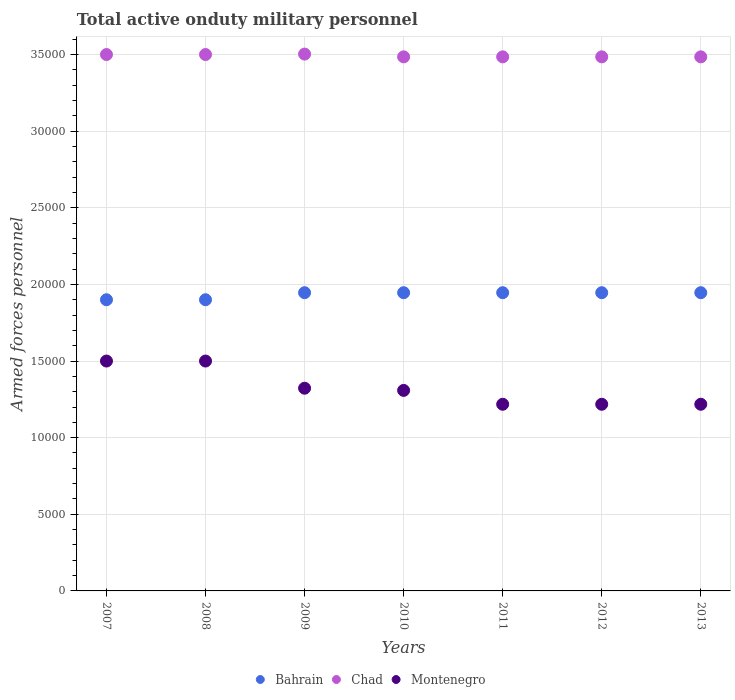Is the number of dotlines equal to the number of legend labels?
Your response must be concise. Yes. What is the number of armed forces personnel in Montenegro in 2011?
Make the answer very short. 1.22e+04. Across all years, what is the maximum number of armed forces personnel in Montenegro?
Provide a short and direct response. 1.50e+04. Across all years, what is the minimum number of armed forces personnel in Montenegro?
Your answer should be very brief. 1.22e+04. In which year was the number of armed forces personnel in Montenegro maximum?
Your answer should be compact. 2007. In which year was the number of armed forces personnel in Chad minimum?
Offer a very short reply. 2010. What is the total number of armed forces personnel in Bahrain in the graph?
Your answer should be very brief. 1.35e+05. What is the difference between the number of armed forces personnel in Montenegro in 2010 and that in 2013?
Your answer should be very brief. 904. What is the difference between the number of armed forces personnel in Montenegro in 2010 and the number of armed forces personnel in Chad in 2009?
Provide a short and direct response. -2.19e+04. What is the average number of armed forces personnel in Bahrain per year?
Provide a short and direct response. 1.93e+04. In the year 2007, what is the difference between the number of armed forces personnel in Montenegro and number of armed forces personnel in Chad?
Your answer should be compact. -2.00e+04. What is the ratio of the number of armed forces personnel in Chad in 2009 to that in 2013?
Your answer should be compact. 1.01. Is the difference between the number of armed forces personnel in Montenegro in 2010 and 2012 greater than the difference between the number of armed forces personnel in Chad in 2010 and 2012?
Offer a very short reply. Yes. What is the difference between the highest and the lowest number of armed forces personnel in Chad?
Offer a terse response. 180. Is the sum of the number of armed forces personnel in Montenegro in 2012 and 2013 greater than the maximum number of armed forces personnel in Bahrain across all years?
Your response must be concise. Yes. Is it the case that in every year, the sum of the number of armed forces personnel in Bahrain and number of armed forces personnel in Chad  is greater than the number of armed forces personnel in Montenegro?
Provide a succinct answer. Yes. Does the number of armed forces personnel in Chad monotonically increase over the years?
Your answer should be compact. No. Is the number of armed forces personnel in Montenegro strictly less than the number of armed forces personnel in Bahrain over the years?
Give a very brief answer. Yes. How many dotlines are there?
Keep it short and to the point. 3. What is the difference between two consecutive major ticks on the Y-axis?
Make the answer very short. 5000. Are the values on the major ticks of Y-axis written in scientific E-notation?
Your answer should be compact. No. Does the graph contain any zero values?
Your answer should be very brief. No. How are the legend labels stacked?
Provide a short and direct response. Horizontal. What is the title of the graph?
Offer a terse response. Total active onduty military personnel. Does "Vanuatu" appear as one of the legend labels in the graph?
Offer a very short reply. No. What is the label or title of the X-axis?
Provide a short and direct response. Years. What is the label or title of the Y-axis?
Your answer should be very brief. Armed forces personnel. What is the Armed forces personnel in Bahrain in 2007?
Provide a succinct answer. 1.90e+04. What is the Armed forces personnel in Chad in 2007?
Offer a terse response. 3.50e+04. What is the Armed forces personnel of Montenegro in 2007?
Your response must be concise. 1.50e+04. What is the Armed forces personnel of Bahrain in 2008?
Provide a succinct answer. 1.90e+04. What is the Armed forces personnel in Chad in 2008?
Keep it short and to the point. 3.50e+04. What is the Armed forces personnel in Montenegro in 2008?
Keep it short and to the point. 1.50e+04. What is the Armed forces personnel of Bahrain in 2009?
Your response must be concise. 1.95e+04. What is the Armed forces personnel of Chad in 2009?
Keep it short and to the point. 3.50e+04. What is the Armed forces personnel of Montenegro in 2009?
Ensure brevity in your answer.  1.32e+04. What is the Armed forces personnel of Bahrain in 2010?
Your answer should be very brief. 1.95e+04. What is the Armed forces personnel in Chad in 2010?
Provide a short and direct response. 3.48e+04. What is the Armed forces personnel in Montenegro in 2010?
Your answer should be compact. 1.31e+04. What is the Armed forces personnel in Bahrain in 2011?
Keep it short and to the point. 1.95e+04. What is the Armed forces personnel of Chad in 2011?
Provide a succinct answer. 3.48e+04. What is the Armed forces personnel of Montenegro in 2011?
Your response must be concise. 1.22e+04. What is the Armed forces personnel of Bahrain in 2012?
Offer a very short reply. 1.95e+04. What is the Armed forces personnel of Chad in 2012?
Provide a succinct answer. 3.48e+04. What is the Armed forces personnel of Montenegro in 2012?
Provide a succinct answer. 1.22e+04. What is the Armed forces personnel of Bahrain in 2013?
Your response must be concise. 1.95e+04. What is the Armed forces personnel of Chad in 2013?
Provide a succinct answer. 3.48e+04. What is the Armed forces personnel of Montenegro in 2013?
Provide a succinct answer. 1.22e+04. Across all years, what is the maximum Armed forces personnel in Bahrain?
Provide a succinct answer. 1.95e+04. Across all years, what is the maximum Armed forces personnel in Chad?
Offer a terse response. 3.50e+04. Across all years, what is the maximum Armed forces personnel of Montenegro?
Keep it short and to the point. 1.50e+04. Across all years, what is the minimum Armed forces personnel of Bahrain?
Ensure brevity in your answer.  1.90e+04. Across all years, what is the minimum Armed forces personnel in Chad?
Your answer should be compact. 3.48e+04. Across all years, what is the minimum Armed forces personnel in Montenegro?
Keep it short and to the point. 1.22e+04. What is the total Armed forces personnel in Bahrain in the graph?
Give a very brief answer. 1.35e+05. What is the total Armed forces personnel in Chad in the graph?
Make the answer very short. 2.44e+05. What is the total Armed forces personnel in Montenegro in the graph?
Give a very brief answer. 9.29e+04. What is the difference between the Armed forces personnel in Bahrain in 2007 and that in 2008?
Offer a terse response. 0. What is the difference between the Armed forces personnel in Montenegro in 2007 and that in 2008?
Your answer should be compact. 0. What is the difference between the Armed forces personnel of Bahrain in 2007 and that in 2009?
Provide a short and direct response. -460. What is the difference between the Armed forces personnel in Chad in 2007 and that in 2009?
Offer a terse response. -30. What is the difference between the Armed forces personnel of Montenegro in 2007 and that in 2009?
Your response must be concise. 1773. What is the difference between the Armed forces personnel in Bahrain in 2007 and that in 2010?
Your response must be concise. -460. What is the difference between the Armed forces personnel in Chad in 2007 and that in 2010?
Keep it short and to the point. 150. What is the difference between the Armed forces personnel in Montenegro in 2007 and that in 2010?
Offer a terse response. 1916. What is the difference between the Armed forces personnel of Bahrain in 2007 and that in 2011?
Ensure brevity in your answer.  -460. What is the difference between the Armed forces personnel of Chad in 2007 and that in 2011?
Your response must be concise. 150. What is the difference between the Armed forces personnel in Montenegro in 2007 and that in 2011?
Keep it short and to the point. 2820. What is the difference between the Armed forces personnel in Bahrain in 2007 and that in 2012?
Offer a terse response. -460. What is the difference between the Armed forces personnel in Chad in 2007 and that in 2012?
Offer a very short reply. 150. What is the difference between the Armed forces personnel of Montenegro in 2007 and that in 2012?
Make the answer very short. 2820. What is the difference between the Armed forces personnel of Bahrain in 2007 and that in 2013?
Offer a terse response. -460. What is the difference between the Armed forces personnel of Chad in 2007 and that in 2013?
Give a very brief answer. 150. What is the difference between the Armed forces personnel in Montenegro in 2007 and that in 2013?
Your response must be concise. 2820. What is the difference between the Armed forces personnel of Bahrain in 2008 and that in 2009?
Provide a succinct answer. -460. What is the difference between the Armed forces personnel of Montenegro in 2008 and that in 2009?
Provide a short and direct response. 1773. What is the difference between the Armed forces personnel in Bahrain in 2008 and that in 2010?
Give a very brief answer. -460. What is the difference between the Armed forces personnel of Chad in 2008 and that in 2010?
Provide a short and direct response. 150. What is the difference between the Armed forces personnel in Montenegro in 2008 and that in 2010?
Provide a succinct answer. 1916. What is the difference between the Armed forces personnel of Bahrain in 2008 and that in 2011?
Make the answer very short. -460. What is the difference between the Armed forces personnel in Chad in 2008 and that in 2011?
Offer a terse response. 150. What is the difference between the Armed forces personnel of Montenegro in 2008 and that in 2011?
Keep it short and to the point. 2820. What is the difference between the Armed forces personnel of Bahrain in 2008 and that in 2012?
Your response must be concise. -460. What is the difference between the Armed forces personnel in Chad in 2008 and that in 2012?
Give a very brief answer. 150. What is the difference between the Armed forces personnel of Montenegro in 2008 and that in 2012?
Provide a succinct answer. 2820. What is the difference between the Armed forces personnel of Bahrain in 2008 and that in 2013?
Your answer should be compact. -460. What is the difference between the Armed forces personnel in Chad in 2008 and that in 2013?
Offer a very short reply. 150. What is the difference between the Armed forces personnel in Montenegro in 2008 and that in 2013?
Your response must be concise. 2820. What is the difference between the Armed forces personnel in Chad in 2009 and that in 2010?
Keep it short and to the point. 180. What is the difference between the Armed forces personnel in Montenegro in 2009 and that in 2010?
Your answer should be very brief. 143. What is the difference between the Armed forces personnel in Bahrain in 2009 and that in 2011?
Your answer should be compact. 0. What is the difference between the Armed forces personnel in Chad in 2009 and that in 2011?
Ensure brevity in your answer.  180. What is the difference between the Armed forces personnel of Montenegro in 2009 and that in 2011?
Give a very brief answer. 1047. What is the difference between the Armed forces personnel in Bahrain in 2009 and that in 2012?
Your response must be concise. 0. What is the difference between the Armed forces personnel in Chad in 2009 and that in 2012?
Offer a very short reply. 180. What is the difference between the Armed forces personnel in Montenegro in 2009 and that in 2012?
Ensure brevity in your answer.  1047. What is the difference between the Armed forces personnel of Bahrain in 2009 and that in 2013?
Your response must be concise. 0. What is the difference between the Armed forces personnel in Chad in 2009 and that in 2013?
Offer a very short reply. 180. What is the difference between the Armed forces personnel in Montenegro in 2009 and that in 2013?
Offer a terse response. 1047. What is the difference between the Armed forces personnel in Bahrain in 2010 and that in 2011?
Your answer should be very brief. 0. What is the difference between the Armed forces personnel of Montenegro in 2010 and that in 2011?
Keep it short and to the point. 904. What is the difference between the Armed forces personnel in Montenegro in 2010 and that in 2012?
Make the answer very short. 904. What is the difference between the Armed forces personnel of Bahrain in 2010 and that in 2013?
Keep it short and to the point. 0. What is the difference between the Armed forces personnel of Montenegro in 2010 and that in 2013?
Give a very brief answer. 904. What is the difference between the Armed forces personnel in Bahrain in 2011 and that in 2013?
Your response must be concise. 0. What is the difference between the Armed forces personnel of Bahrain in 2012 and that in 2013?
Give a very brief answer. 0. What is the difference between the Armed forces personnel in Chad in 2012 and that in 2013?
Provide a short and direct response. 0. What is the difference between the Armed forces personnel of Montenegro in 2012 and that in 2013?
Your answer should be compact. 0. What is the difference between the Armed forces personnel in Bahrain in 2007 and the Armed forces personnel in Chad in 2008?
Offer a very short reply. -1.60e+04. What is the difference between the Armed forces personnel of Bahrain in 2007 and the Armed forces personnel of Montenegro in 2008?
Your answer should be compact. 4000. What is the difference between the Armed forces personnel of Bahrain in 2007 and the Armed forces personnel of Chad in 2009?
Your answer should be very brief. -1.60e+04. What is the difference between the Armed forces personnel in Bahrain in 2007 and the Armed forces personnel in Montenegro in 2009?
Provide a short and direct response. 5773. What is the difference between the Armed forces personnel in Chad in 2007 and the Armed forces personnel in Montenegro in 2009?
Offer a very short reply. 2.18e+04. What is the difference between the Armed forces personnel of Bahrain in 2007 and the Armed forces personnel of Chad in 2010?
Ensure brevity in your answer.  -1.58e+04. What is the difference between the Armed forces personnel of Bahrain in 2007 and the Armed forces personnel of Montenegro in 2010?
Your answer should be very brief. 5916. What is the difference between the Armed forces personnel in Chad in 2007 and the Armed forces personnel in Montenegro in 2010?
Your response must be concise. 2.19e+04. What is the difference between the Armed forces personnel of Bahrain in 2007 and the Armed forces personnel of Chad in 2011?
Your answer should be compact. -1.58e+04. What is the difference between the Armed forces personnel of Bahrain in 2007 and the Armed forces personnel of Montenegro in 2011?
Your response must be concise. 6820. What is the difference between the Armed forces personnel of Chad in 2007 and the Armed forces personnel of Montenegro in 2011?
Your response must be concise. 2.28e+04. What is the difference between the Armed forces personnel in Bahrain in 2007 and the Armed forces personnel in Chad in 2012?
Make the answer very short. -1.58e+04. What is the difference between the Armed forces personnel in Bahrain in 2007 and the Armed forces personnel in Montenegro in 2012?
Give a very brief answer. 6820. What is the difference between the Armed forces personnel in Chad in 2007 and the Armed forces personnel in Montenegro in 2012?
Provide a succinct answer. 2.28e+04. What is the difference between the Armed forces personnel of Bahrain in 2007 and the Armed forces personnel of Chad in 2013?
Your response must be concise. -1.58e+04. What is the difference between the Armed forces personnel of Bahrain in 2007 and the Armed forces personnel of Montenegro in 2013?
Ensure brevity in your answer.  6820. What is the difference between the Armed forces personnel of Chad in 2007 and the Armed forces personnel of Montenegro in 2013?
Your response must be concise. 2.28e+04. What is the difference between the Armed forces personnel in Bahrain in 2008 and the Armed forces personnel in Chad in 2009?
Offer a very short reply. -1.60e+04. What is the difference between the Armed forces personnel of Bahrain in 2008 and the Armed forces personnel of Montenegro in 2009?
Your response must be concise. 5773. What is the difference between the Armed forces personnel in Chad in 2008 and the Armed forces personnel in Montenegro in 2009?
Offer a very short reply. 2.18e+04. What is the difference between the Armed forces personnel in Bahrain in 2008 and the Armed forces personnel in Chad in 2010?
Give a very brief answer. -1.58e+04. What is the difference between the Armed forces personnel in Bahrain in 2008 and the Armed forces personnel in Montenegro in 2010?
Provide a short and direct response. 5916. What is the difference between the Armed forces personnel in Chad in 2008 and the Armed forces personnel in Montenegro in 2010?
Offer a terse response. 2.19e+04. What is the difference between the Armed forces personnel in Bahrain in 2008 and the Armed forces personnel in Chad in 2011?
Make the answer very short. -1.58e+04. What is the difference between the Armed forces personnel in Bahrain in 2008 and the Armed forces personnel in Montenegro in 2011?
Offer a very short reply. 6820. What is the difference between the Armed forces personnel of Chad in 2008 and the Armed forces personnel of Montenegro in 2011?
Your answer should be compact. 2.28e+04. What is the difference between the Armed forces personnel in Bahrain in 2008 and the Armed forces personnel in Chad in 2012?
Make the answer very short. -1.58e+04. What is the difference between the Armed forces personnel of Bahrain in 2008 and the Armed forces personnel of Montenegro in 2012?
Make the answer very short. 6820. What is the difference between the Armed forces personnel in Chad in 2008 and the Armed forces personnel in Montenegro in 2012?
Your answer should be compact. 2.28e+04. What is the difference between the Armed forces personnel in Bahrain in 2008 and the Armed forces personnel in Chad in 2013?
Give a very brief answer. -1.58e+04. What is the difference between the Armed forces personnel in Bahrain in 2008 and the Armed forces personnel in Montenegro in 2013?
Offer a terse response. 6820. What is the difference between the Armed forces personnel in Chad in 2008 and the Armed forces personnel in Montenegro in 2013?
Provide a succinct answer. 2.28e+04. What is the difference between the Armed forces personnel of Bahrain in 2009 and the Armed forces personnel of Chad in 2010?
Offer a terse response. -1.54e+04. What is the difference between the Armed forces personnel in Bahrain in 2009 and the Armed forces personnel in Montenegro in 2010?
Your response must be concise. 6376. What is the difference between the Armed forces personnel in Chad in 2009 and the Armed forces personnel in Montenegro in 2010?
Provide a short and direct response. 2.19e+04. What is the difference between the Armed forces personnel of Bahrain in 2009 and the Armed forces personnel of Chad in 2011?
Offer a terse response. -1.54e+04. What is the difference between the Armed forces personnel in Bahrain in 2009 and the Armed forces personnel in Montenegro in 2011?
Offer a very short reply. 7280. What is the difference between the Armed forces personnel in Chad in 2009 and the Armed forces personnel in Montenegro in 2011?
Keep it short and to the point. 2.28e+04. What is the difference between the Armed forces personnel in Bahrain in 2009 and the Armed forces personnel in Chad in 2012?
Provide a short and direct response. -1.54e+04. What is the difference between the Armed forces personnel in Bahrain in 2009 and the Armed forces personnel in Montenegro in 2012?
Keep it short and to the point. 7280. What is the difference between the Armed forces personnel in Chad in 2009 and the Armed forces personnel in Montenegro in 2012?
Keep it short and to the point. 2.28e+04. What is the difference between the Armed forces personnel in Bahrain in 2009 and the Armed forces personnel in Chad in 2013?
Provide a short and direct response. -1.54e+04. What is the difference between the Armed forces personnel of Bahrain in 2009 and the Armed forces personnel of Montenegro in 2013?
Offer a very short reply. 7280. What is the difference between the Armed forces personnel in Chad in 2009 and the Armed forces personnel in Montenegro in 2013?
Offer a terse response. 2.28e+04. What is the difference between the Armed forces personnel in Bahrain in 2010 and the Armed forces personnel in Chad in 2011?
Provide a succinct answer. -1.54e+04. What is the difference between the Armed forces personnel in Bahrain in 2010 and the Armed forces personnel in Montenegro in 2011?
Your response must be concise. 7280. What is the difference between the Armed forces personnel in Chad in 2010 and the Armed forces personnel in Montenegro in 2011?
Offer a terse response. 2.27e+04. What is the difference between the Armed forces personnel in Bahrain in 2010 and the Armed forces personnel in Chad in 2012?
Your answer should be very brief. -1.54e+04. What is the difference between the Armed forces personnel in Bahrain in 2010 and the Armed forces personnel in Montenegro in 2012?
Your response must be concise. 7280. What is the difference between the Armed forces personnel in Chad in 2010 and the Armed forces personnel in Montenegro in 2012?
Offer a very short reply. 2.27e+04. What is the difference between the Armed forces personnel of Bahrain in 2010 and the Armed forces personnel of Chad in 2013?
Provide a short and direct response. -1.54e+04. What is the difference between the Armed forces personnel in Bahrain in 2010 and the Armed forces personnel in Montenegro in 2013?
Provide a succinct answer. 7280. What is the difference between the Armed forces personnel of Chad in 2010 and the Armed forces personnel of Montenegro in 2013?
Make the answer very short. 2.27e+04. What is the difference between the Armed forces personnel in Bahrain in 2011 and the Armed forces personnel in Chad in 2012?
Offer a very short reply. -1.54e+04. What is the difference between the Armed forces personnel in Bahrain in 2011 and the Armed forces personnel in Montenegro in 2012?
Provide a succinct answer. 7280. What is the difference between the Armed forces personnel of Chad in 2011 and the Armed forces personnel of Montenegro in 2012?
Your answer should be compact. 2.27e+04. What is the difference between the Armed forces personnel of Bahrain in 2011 and the Armed forces personnel of Chad in 2013?
Give a very brief answer. -1.54e+04. What is the difference between the Armed forces personnel in Bahrain in 2011 and the Armed forces personnel in Montenegro in 2013?
Make the answer very short. 7280. What is the difference between the Armed forces personnel of Chad in 2011 and the Armed forces personnel of Montenegro in 2013?
Provide a short and direct response. 2.27e+04. What is the difference between the Armed forces personnel in Bahrain in 2012 and the Armed forces personnel in Chad in 2013?
Keep it short and to the point. -1.54e+04. What is the difference between the Armed forces personnel of Bahrain in 2012 and the Armed forces personnel of Montenegro in 2013?
Offer a very short reply. 7280. What is the difference between the Armed forces personnel in Chad in 2012 and the Armed forces personnel in Montenegro in 2013?
Provide a short and direct response. 2.27e+04. What is the average Armed forces personnel in Bahrain per year?
Your answer should be compact. 1.93e+04. What is the average Armed forces personnel in Chad per year?
Provide a succinct answer. 3.49e+04. What is the average Armed forces personnel of Montenegro per year?
Your answer should be very brief. 1.33e+04. In the year 2007, what is the difference between the Armed forces personnel in Bahrain and Armed forces personnel in Chad?
Make the answer very short. -1.60e+04. In the year 2007, what is the difference between the Armed forces personnel in Bahrain and Armed forces personnel in Montenegro?
Provide a short and direct response. 4000. In the year 2007, what is the difference between the Armed forces personnel in Chad and Armed forces personnel in Montenegro?
Give a very brief answer. 2.00e+04. In the year 2008, what is the difference between the Armed forces personnel in Bahrain and Armed forces personnel in Chad?
Offer a very short reply. -1.60e+04. In the year 2008, what is the difference between the Armed forces personnel in Bahrain and Armed forces personnel in Montenegro?
Your answer should be compact. 4000. In the year 2008, what is the difference between the Armed forces personnel in Chad and Armed forces personnel in Montenegro?
Your answer should be compact. 2.00e+04. In the year 2009, what is the difference between the Armed forces personnel of Bahrain and Armed forces personnel of Chad?
Give a very brief answer. -1.56e+04. In the year 2009, what is the difference between the Armed forces personnel in Bahrain and Armed forces personnel in Montenegro?
Offer a terse response. 6233. In the year 2009, what is the difference between the Armed forces personnel of Chad and Armed forces personnel of Montenegro?
Make the answer very short. 2.18e+04. In the year 2010, what is the difference between the Armed forces personnel in Bahrain and Armed forces personnel in Chad?
Your answer should be very brief. -1.54e+04. In the year 2010, what is the difference between the Armed forces personnel in Bahrain and Armed forces personnel in Montenegro?
Provide a short and direct response. 6376. In the year 2010, what is the difference between the Armed forces personnel in Chad and Armed forces personnel in Montenegro?
Your response must be concise. 2.18e+04. In the year 2011, what is the difference between the Armed forces personnel in Bahrain and Armed forces personnel in Chad?
Provide a succinct answer. -1.54e+04. In the year 2011, what is the difference between the Armed forces personnel of Bahrain and Armed forces personnel of Montenegro?
Provide a succinct answer. 7280. In the year 2011, what is the difference between the Armed forces personnel of Chad and Armed forces personnel of Montenegro?
Your answer should be compact. 2.27e+04. In the year 2012, what is the difference between the Armed forces personnel of Bahrain and Armed forces personnel of Chad?
Your response must be concise. -1.54e+04. In the year 2012, what is the difference between the Armed forces personnel in Bahrain and Armed forces personnel in Montenegro?
Your answer should be very brief. 7280. In the year 2012, what is the difference between the Armed forces personnel of Chad and Armed forces personnel of Montenegro?
Offer a terse response. 2.27e+04. In the year 2013, what is the difference between the Armed forces personnel of Bahrain and Armed forces personnel of Chad?
Offer a very short reply. -1.54e+04. In the year 2013, what is the difference between the Armed forces personnel of Bahrain and Armed forces personnel of Montenegro?
Your answer should be compact. 7280. In the year 2013, what is the difference between the Armed forces personnel in Chad and Armed forces personnel in Montenegro?
Your answer should be compact. 2.27e+04. What is the ratio of the Armed forces personnel of Bahrain in 2007 to that in 2008?
Ensure brevity in your answer.  1. What is the ratio of the Armed forces personnel of Chad in 2007 to that in 2008?
Your answer should be very brief. 1. What is the ratio of the Armed forces personnel in Montenegro in 2007 to that in 2008?
Offer a very short reply. 1. What is the ratio of the Armed forces personnel of Bahrain in 2007 to that in 2009?
Provide a succinct answer. 0.98. What is the ratio of the Armed forces personnel in Chad in 2007 to that in 2009?
Your answer should be compact. 1. What is the ratio of the Armed forces personnel in Montenegro in 2007 to that in 2009?
Keep it short and to the point. 1.13. What is the ratio of the Armed forces personnel in Bahrain in 2007 to that in 2010?
Offer a terse response. 0.98. What is the ratio of the Armed forces personnel of Montenegro in 2007 to that in 2010?
Keep it short and to the point. 1.15. What is the ratio of the Armed forces personnel in Bahrain in 2007 to that in 2011?
Your answer should be very brief. 0.98. What is the ratio of the Armed forces personnel of Montenegro in 2007 to that in 2011?
Provide a succinct answer. 1.23. What is the ratio of the Armed forces personnel of Bahrain in 2007 to that in 2012?
Your response must be concise. 0.98. What is the ratio of the Armed forces personnel in Chad in 2007 to that in 2012?
Your response must be concise. 1. What is the ratio of the Armed forces personnel of Montenegro in 2007 to that in 2012?
Give a very brief answer. 1.23. What is the ratio of the Armed forces personnel of Bahrain in 2007 to that in 2013?
Your answer should be compact. 0.98. What is the ratio of the Armed forces personnel of Chad in 2007 to that in 2013?
Provide a short and direct response. 1. What is the ratio of the Armed forces personnel of Montenegro in 2007 to that in 2013?
Ensure brevity in your answer.  1.23. What is the ratio of the Armed forces personnel in Bahrain in 2008 to that in 2009?
Offer a terse response. 0.98. What is the ratio of the Armed forces personnel in Chad in 2008 to that in 2009?
Provide a succinct answer. 1. What is the ratio of the Armed forces personnel of Montenegro in 2008 to that in 2009?
Your answer should be very brief. 1.13. What is the ratio of the Armed forces personnel of Bahrain in 2008 to that in 2010?
Your answer should be compact. 0.98. What is the ratio of the Armed forces personnel of Montenegro in 2008 to that in 2010?
Your answer should be compact. 1.15. What is the ratio of the Armed forces personnel of Bahrain in 2008 to that in 2011?
Ensure brevity in your answer.  0.98. What is the ratio of the Armed forces personnel of Montenegro in 2008 to that in 2011?
Provide a succinct answer. 1.23. What is the ratio of the Armed forces personnel of Bahrain in 2008 to that in 2012?
Offer a very short reply. 0.98. What is the ratio of the Armed forces personnel in Chad in 2008 to that in 2012?
Provide a succinct answer. 1. What is the ratio of the Armed forces personnel in Montenegro in 2008 to that in 2012?
Offer a terse response. 1.23. What is the ratio of the Armed forces personnel in Bahrain in 2008 to that in 2013?
Your answer should be very brief. 0.98. What is the ratio of the Armed forces personnel of Chad in 2008 to that in 2013?
Give a very brief answer. 1. What is the ratio of the Armed forces personnel of Montenegro in 2008 to that in 2013?
Offer a terse response. 1.23. What is the ratio of the Armed forces personnel in Montenegro in 2009 to that in 2010?
Offer a terse response. 1.01. What is the ratio of the Armed forces personnel in Chad in 2009 to that in 2011?
Your answer should be very brief. 1.01. What is the ratio of the Armed forces personnel of Montenegro in 2009 to that in 2011?
Your response must be concise. 1.09. What is the ratio of the Armed forces personnel of Chad in 2009 to that in 2012?
Offer a terse response. 1.01. What is the ratio of the Armed forces personnel in Montenegro in 2009 to that in 2012?
Your answer should be very brief. 1.09. What is the ratio of the Armed forces personnel of Montenegro in 2009 to that in 2013?
Your response must be concise. 1.09. What is the ratio of the Armed forces personnel of Bahrain in 2010 to that in 2011?
Provide a succinct answer. 1. What is the ratio of the Armed forces personnel in Montenegro in 2010 to that in 2011?
Give a very brief answer. 1.07. What is the ratio of the Armed forces personnel of Bahrain in 2010 to that in 2012?
Make the answer very short. 1. What is the ratio of the Armed forces personnel in Chad in 2010 to that in 2012?
Your answer should be compact. 1. What is the ratio of the Armed forces personnel of Montenegro in 2010 to that in 2012?
Your response must be concise. 1.07. What is the ratio of the Armed forces personnel of Bahrain in 2010 to that in 2013?
Offer a terse response. 1. What is the ratio of the Armed forces personnel of Montenegro in 2010 to that in 2013?
Provide a succinct answer. 1.07. What is the ratio of the Armed forces personnel in Bahrain in 2011 to that in 2012?
Your answer should be very brief. 1. What is the ratio of the Armed forces personnel in Bahrain in 2012 to that in 2013?
Your answer should be compact. 1. What is the ratio of the Armed forces personnel in Chad in 2012 to that in 2013?
Keep it short and to the point. 1. What is the difference between the highest and the second highest Armed forces personnel of Bahrain?
Keep it short and to the point. 0. What is the difference between the highest and the lowest Armed forces personnel in Bahrain?
Give a very brief answer. 460. What is the difference between the highest and the lowest Armed forces personnel in Chad?
Offer a terse response. 180. What is the difference between the highest and the lowest Armed forces personnel in Montenegro?
Your answer should be compact. 2820. 